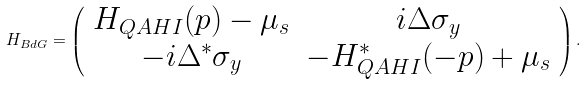<formula> <loc_0><loc_0><loc_500><loc_500>H _ { B d G } = \left ( \begin{array} { c c } H _ { Q A H I } ( p ) - \mu _ { s } & i \Delta \sigma _ { y } \\ - i \Delta ^ { \ast } \sigma _ { y } & - H _ { Q A H I } ^ { \ast } ( - p ) + \mu _ { s } \\ \end{array} \right ) .</formula> 